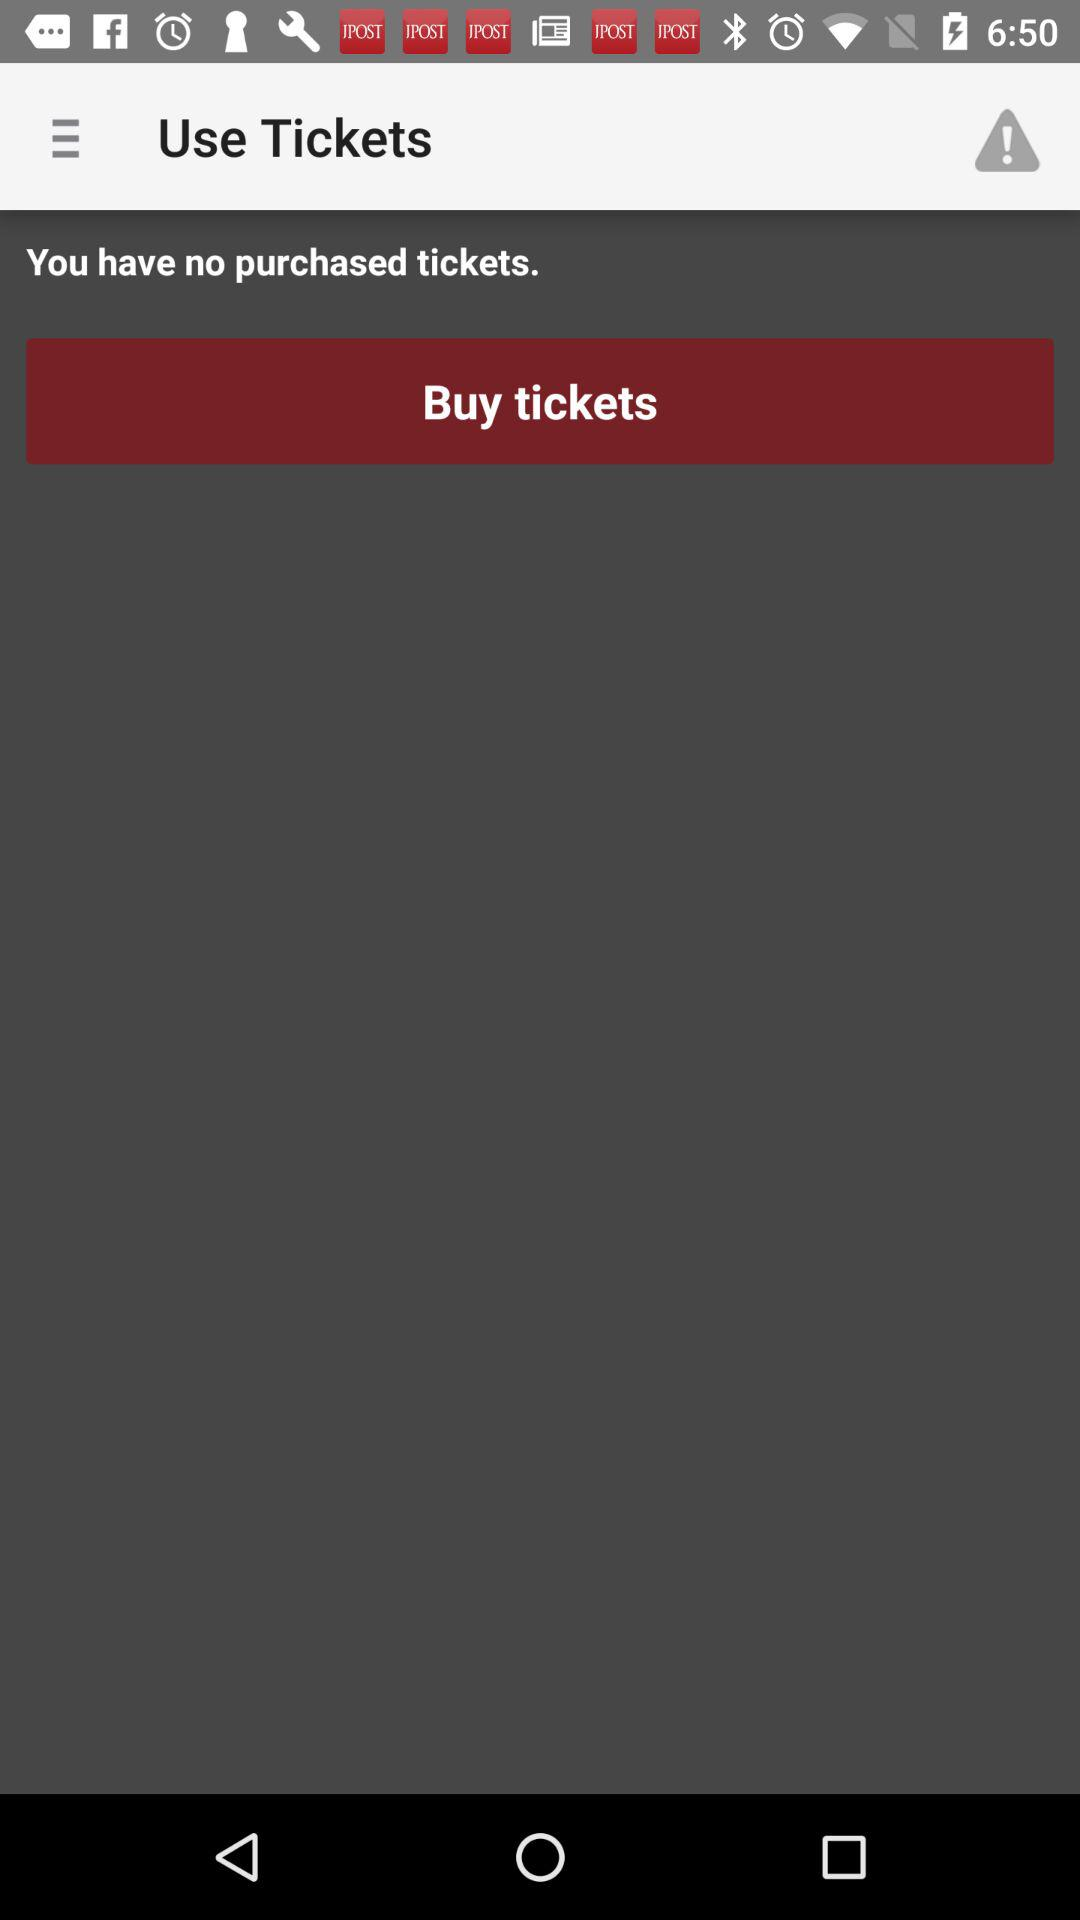Are there any purchased tickets? There are no purchased tickets. 